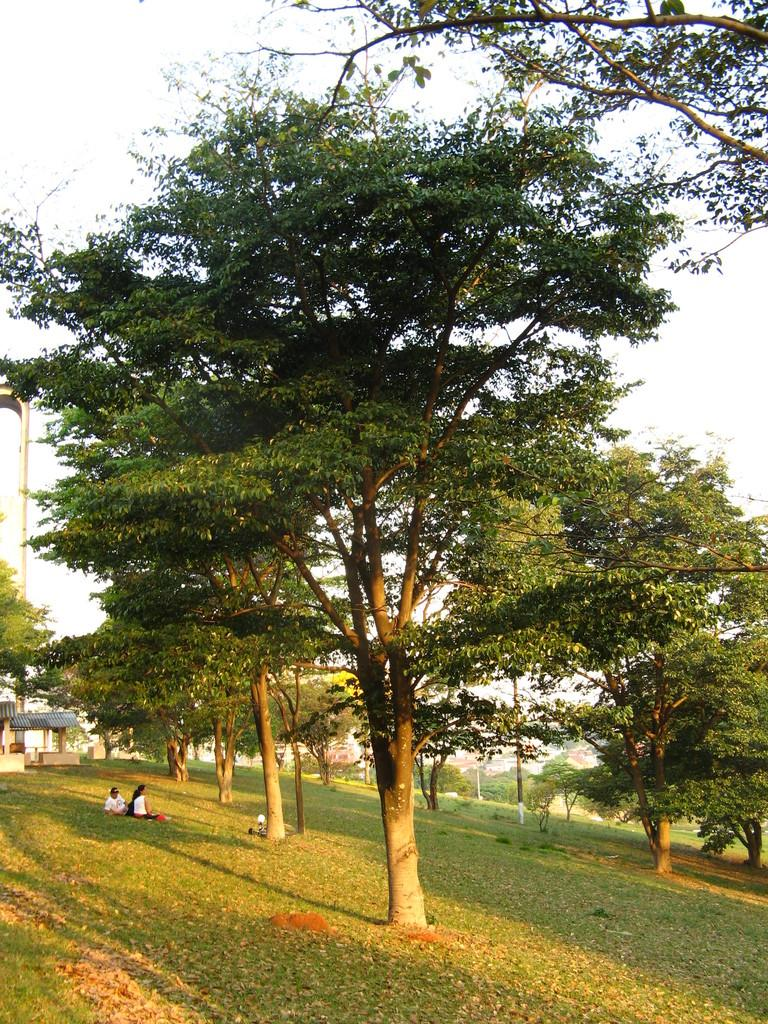What type of natural vegetation can be seen in the image? There are trees in the image. What are the people in the image doing? The people in the image are sitting. What structure is located on the left side of the image? There is a shed on the left side of the image. What is visible in the background of the image? The sky and a pole are visible in the background of the image. What type of umbrella is the son holding for his father in the image? There is no son or father present in the image, and therefore no umbrella can be observed. 